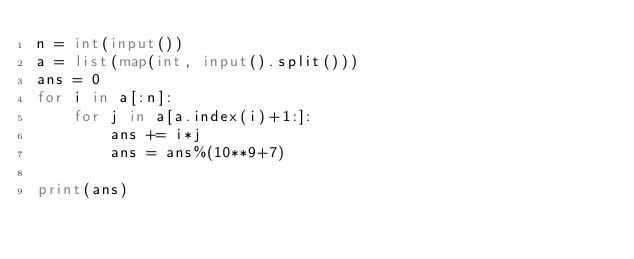Convert code to text. <code><loc_0><loc_0><loc_500><loc_500><_Python_>n = int(input())
a = list(map(int, input().split()))
ans = 0
for i in a[:n]:
    for j in a[a.index(i)+1:]:
        ans += i*j
        ans = ans%(10**9+7)
        
print(ans)</code> 